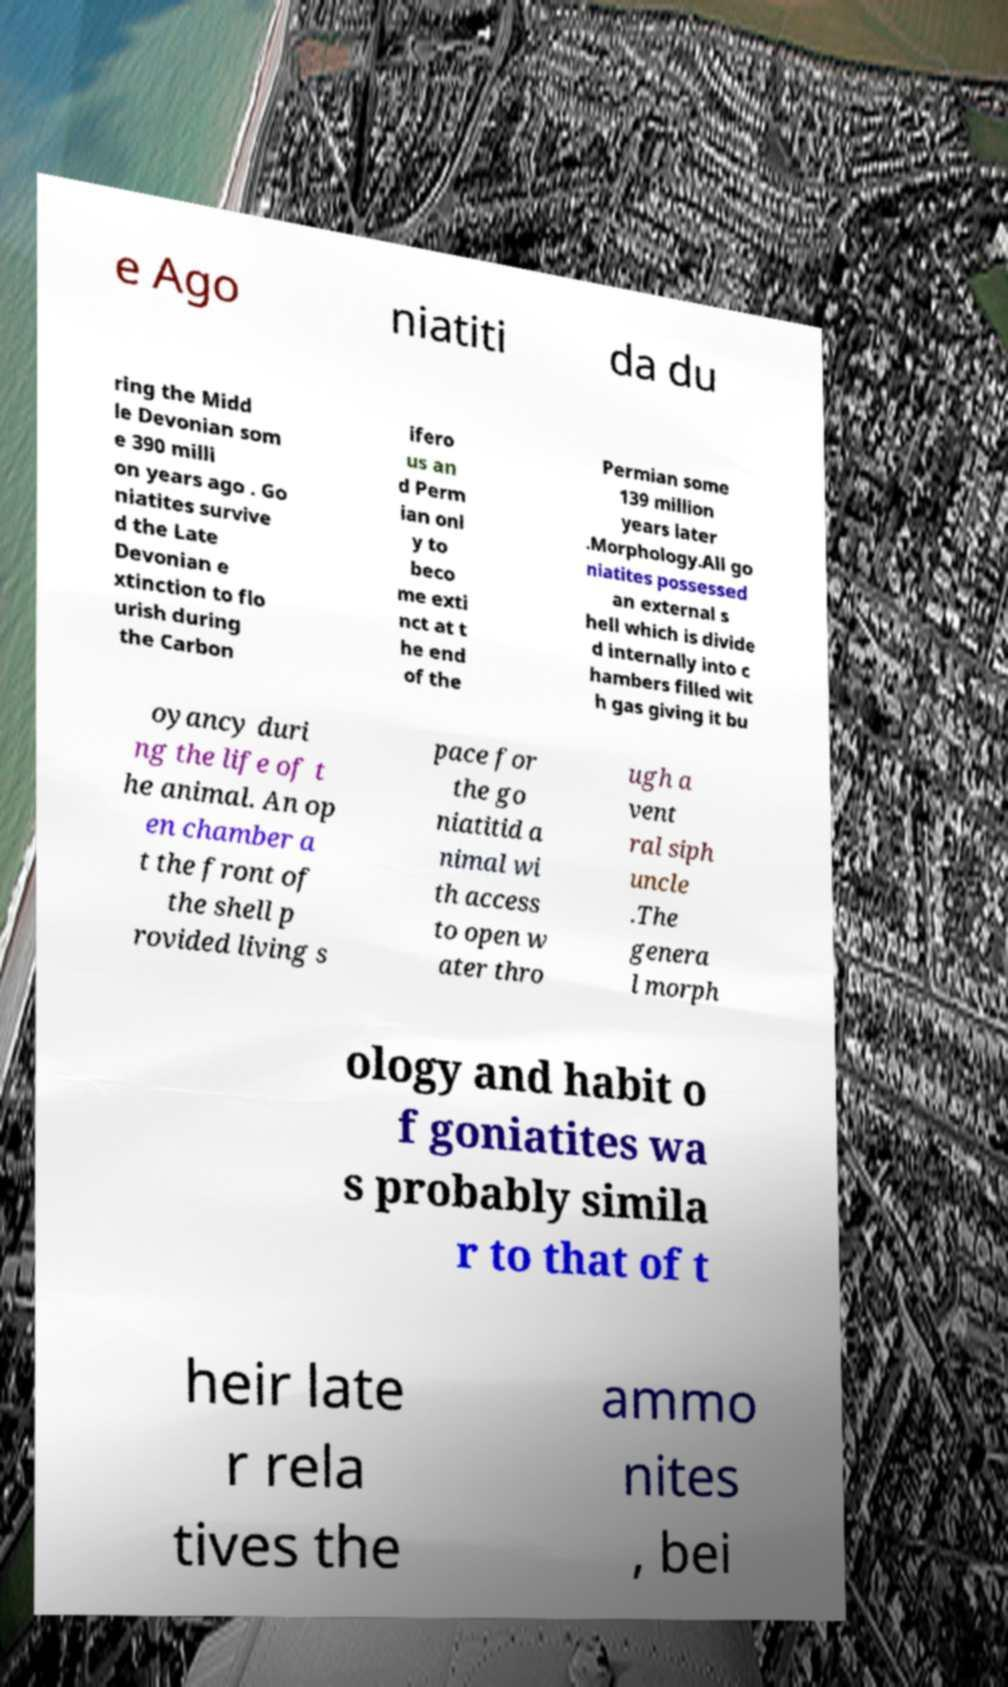Please read and relay the text visible in this image. What does it say? e Ago niatiti da du ring the Midd le Devonian som e 390 milli on years ago . Go niatites survive d the Late Devonian e xtinction to flo urish during the Carbon ifero us an d Perm ian onl y to beco me exti nct at t he end of the Permian some 139 million years later .Morphology.All go niatites possessed an external s hell which is divide d internally into c hambers filled wit h gas giving it bu oyancy duri ng the life of t he animal. An op en chamber a t the front of the shell p rovided living s pace for the go niatitid a nimal wi th access to open w ater thro ugh a vent ral siph uncle .The genera l morph ology and habit o f goniatites wa s probably simila r to that of t heir late r rela tives the ammo nites , bei 